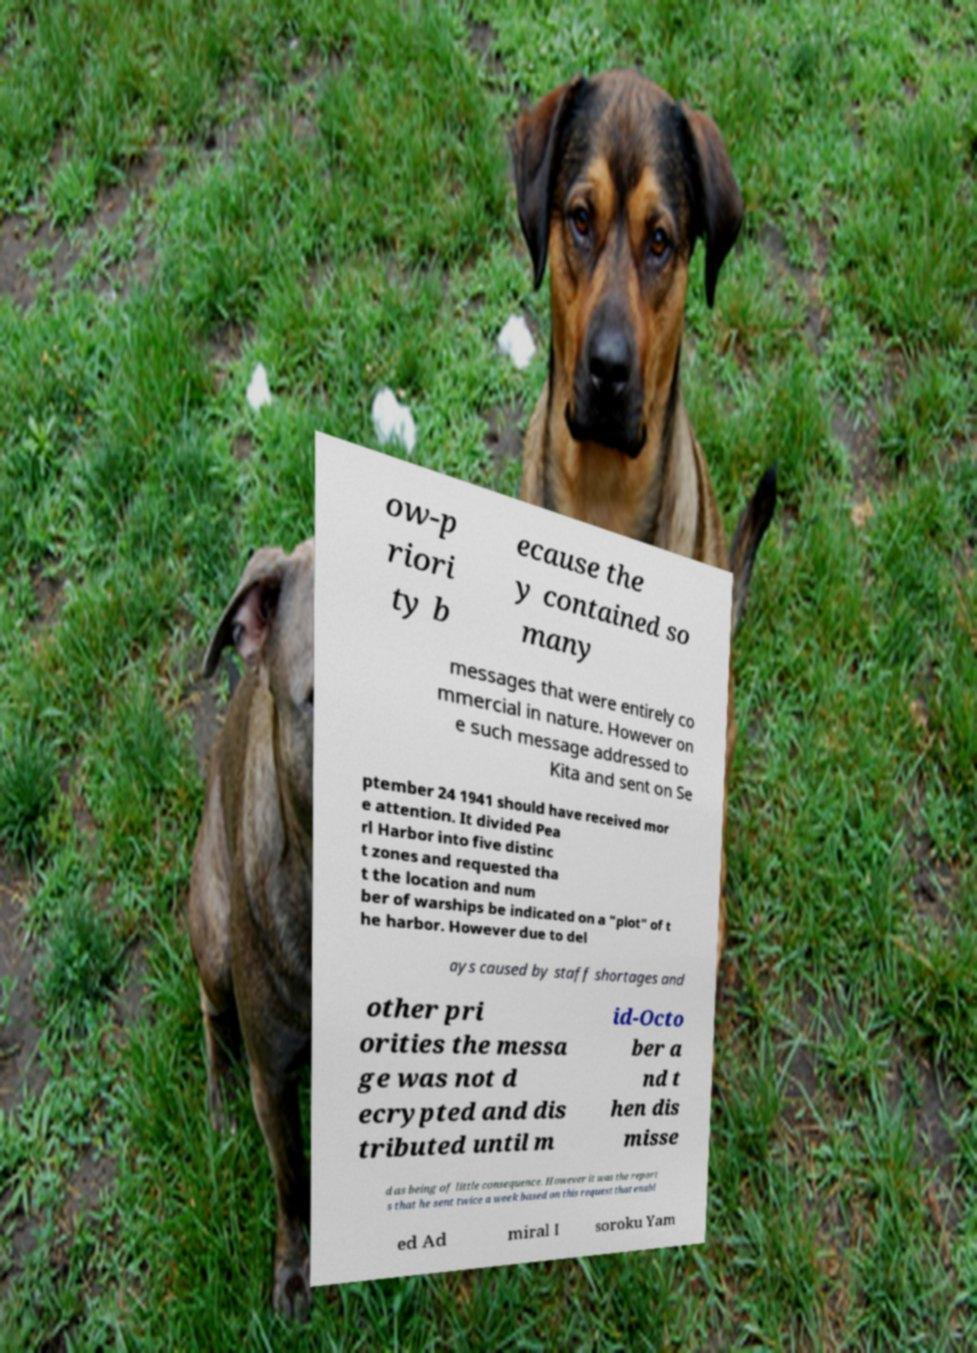Can you read and provide the text displayed in the image?This photo seems to have some interesting text. Can you extract and type it out for me? ow-p riori ty b ecause the y contained so many messages that were entirely co mmercial in nature. However on e such message addressed to Kita and sent on Se ptember 24 1941 should have received mor e attention. It divided Pea rl Harbor into five distinc t zones and requested tha t the location and num ber of warships be indicated on a "plot" of t he harbor. However due to del ays caused by staff shortages and other pri orities the messa ge was not d ecrypted and dis tributed until m id-Octo ber a nd t hen dis misse d as being of little consequence. However it was the report s that he sent twice a week based on this request that enabl ed Ad miral I soroku Yam 